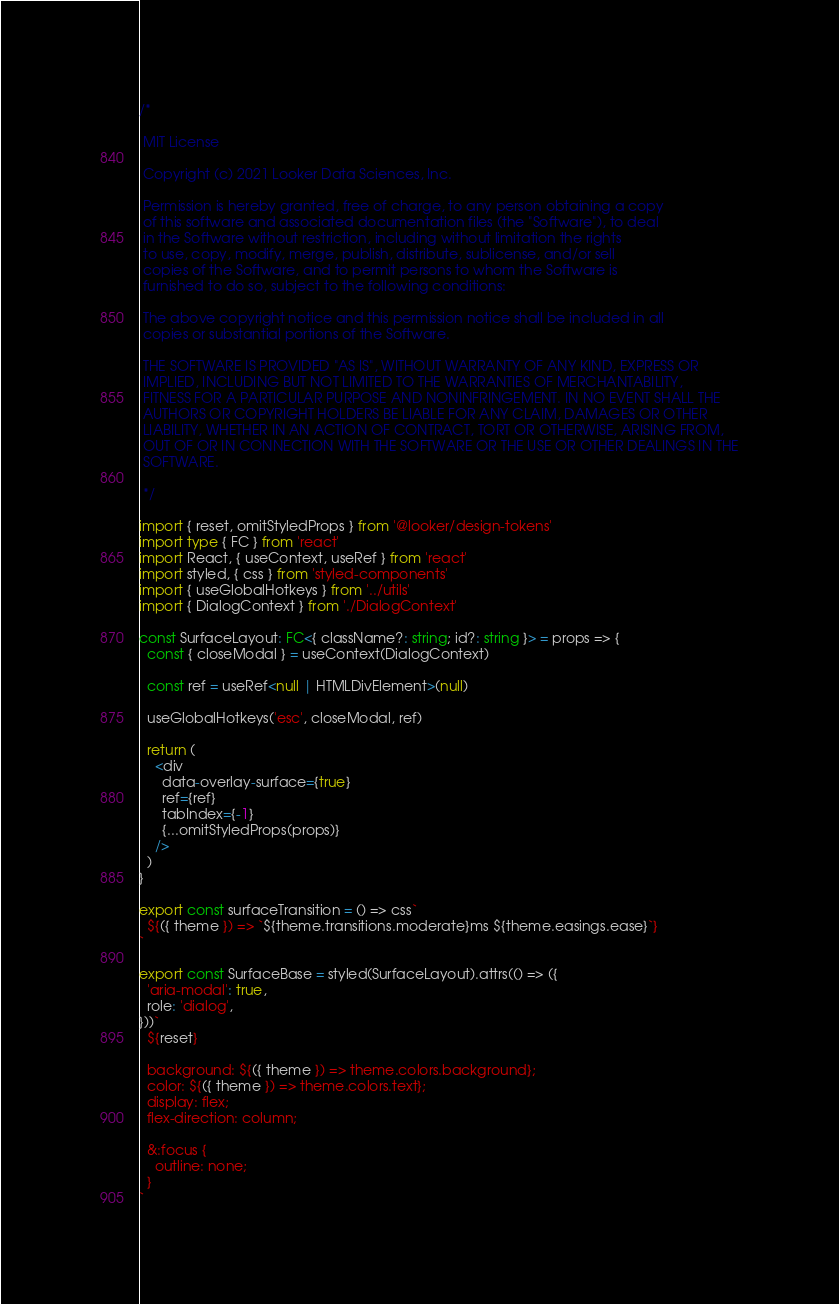Convert code to text. <code><loc_0><loc_0><loc_500><loc_500><_TypeScript_>/*

 MIT License

 Copyright (c) 2021 Looker Data Sciences, Inc.

 Permission is hereby granted, free of charge, to any person obtaining a copy
 of this software and associated documentation files (the "Software"), to deal
 in the Software without restriction, including without limitation the rights
 to use, copy, modify, merge, publish, distribute, sublicense, and/or sell
 copies of the Software, and to permit persons to whom the Software is
 furnished to do so, subject to the following conditions:

 The above copyright notice and this permission notice shall be included in all
 copies or substantial portions of the Software.

 THE SOFTWARE IS PROVIDED "AS IS", WITHOUT WARRANTY OF ANY KIND, EXPRESS OR
 IMPLIED, INCLUDING BUT NOT LIMITED TO THE WARRANTIES OF MERCHANTABILITY,
 FITNESS FOR A PARTICULAR PURPOSE AND NONINFRINGEMENT. IN NO EVENT SHALL THE
 AUTHORS OR COPYRIGHT HOLDERS BE LIABLE FOR ANY CLAIM, DAMAGES OR OTHER
 LIABILITY, WHETHER IN AN ACTION OF CONTRACT, TORT OR OTHERWISE, ARISING FROM,
 OUT OF OR IN CONNECTION WITH THE SOFTWARE OR THE USE OR OTHER DEALINGS IN THE
 SOFTWARE.

 */

import { reset, omitStyledProps } from '@looker/design-tokens'
import type { FC } from 'react'
import React, { useContext, useRef } from 'react'
import styled, { css } from 'styled-components'
import { useGlobalHotkeys } from '../utils'
import { DialogContext } from './DialogContext'

const SurfaceLayout: FC<{ className?: string; id?: string }> = props => {
  const { closeModal } = useContext(DialogContext)

  const ref = useRef<null | HTMLDivElement>(null)

  useGlobalHotkeys('esc', closeModal, ref)

  return (
    <div
      data-overlay-surface={true}
      ref={ref}
      tabIndex={-1}
      {...omitStyledProps(props)}
    />
  )
}

export const surfaceTransition = () => css`
  ${({ theme }) => `${theme.transitions.moderate}ms ${theme.easings.ease}`}
`

export const SurfaceBase = styled(SurfaceLayout).attrs(() => ({
  'aria-modal': true,
  role: 'dialog',
}))`
  ${reset}

  background: ${({ theme }) => theme.colors.background};
  color: ${({ theme }) => theme.colors.text};
  display: flex;
  flex-direction: column;

  &:focus {
    outline: none;
  }
`
</code> 